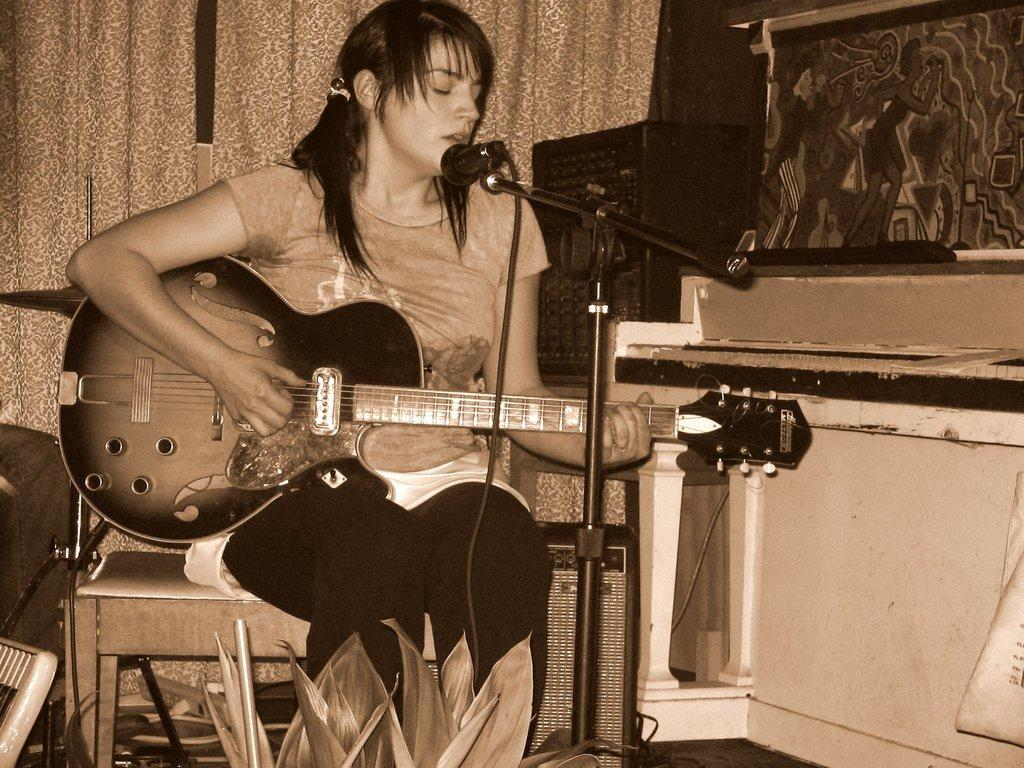What is the woman in the image holding? The woman is holding a guitar in the image. What object is in front of the woman? There is a microphone in front of the woman. What can be seen in the background of the image? There is a curtain in the background of the image. What type of coat is the minister wearing in the image? There is no minister or coat present in the image. 